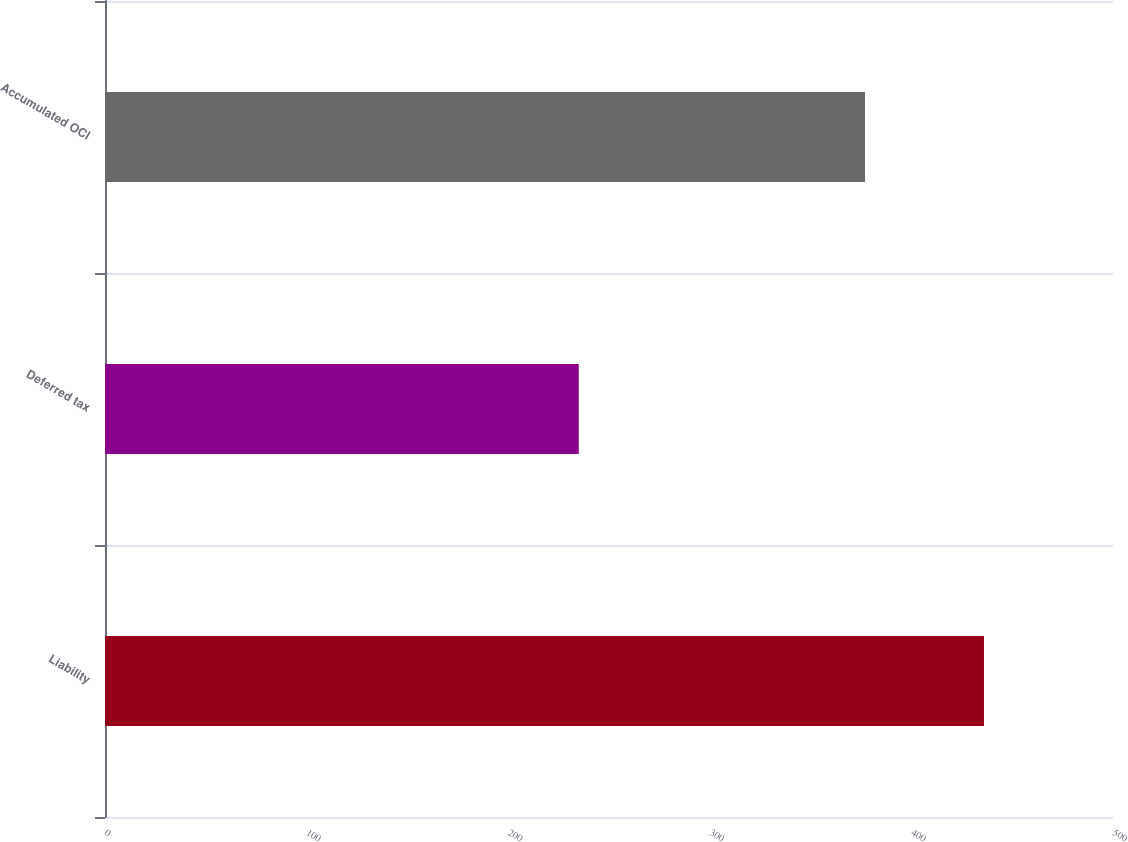Convert chart to OTSL. <chart><loc_0><loc_0><loc_500><loc_500><bar_chart><fcel>Liability<fcel>Deferred tax<fcel>Accumulated OCI<nl><fcel>436<fcel>235<fcel>377<nl></chart> 